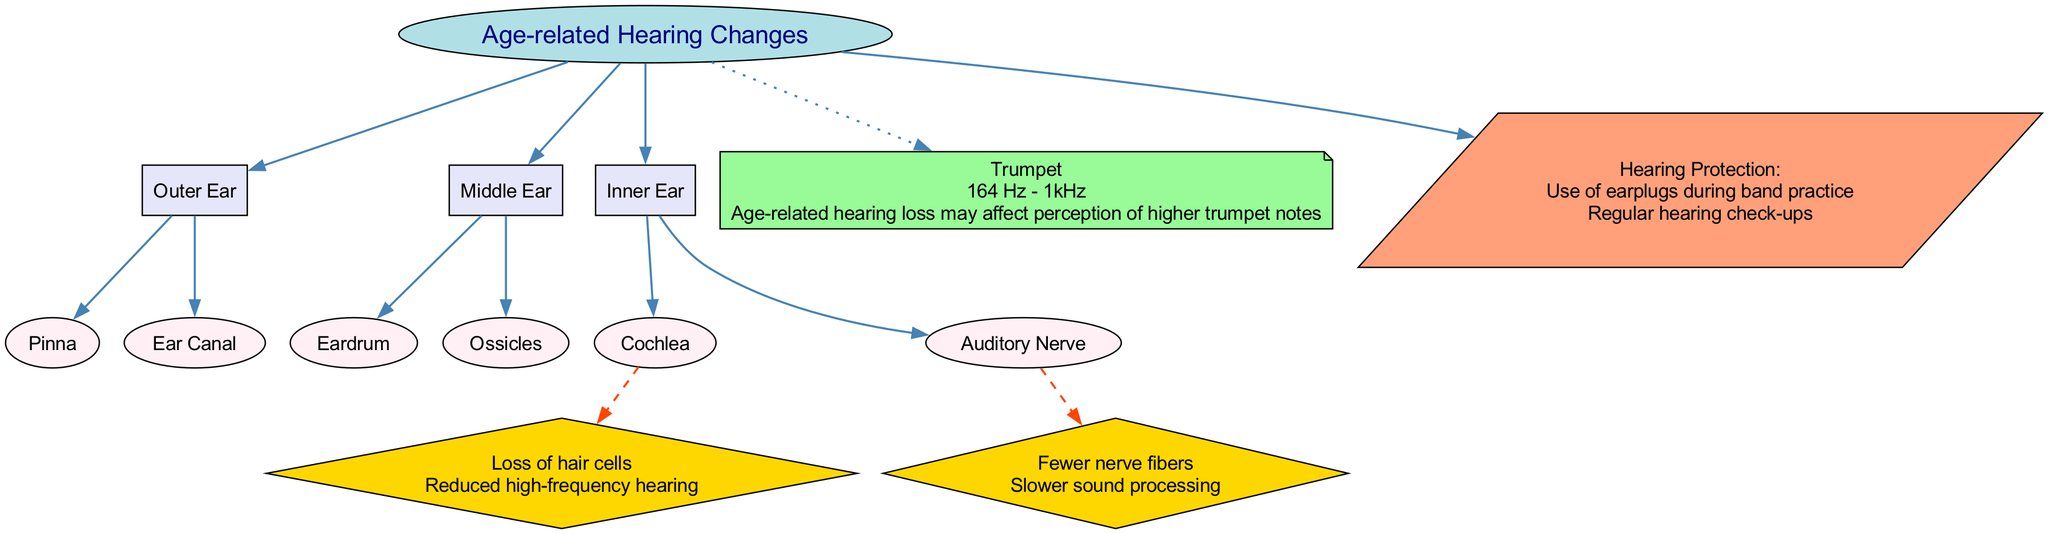What is the central topic of the diagram? The diagram's title indicates that the central topic is "Age-related Hearing Changes." Therefore, looking for the central node labeled as the main focus of the diagram leads directly to this answer.
Answer: Age-related Hearing Changes How many main structures are depicted? The diagram includes three main structures: Outer Ear, Middle Ear, and Inner Ear. By counting the nodes connected to the central topic, we arrive at this total.
Answer: 3 What component belongs to the Middle Ear? The component "Ossicles" is listed under the Middle Ear section in the diagram. Identifying the components associated with each main structure will provide the answer.
Answer: Ossicles What change occurs in the Cochlea with age? The diagram states "Loss of hair cells" as the age-related change in the Cochlea. This answer is obtained directly from the node corresponding to Cochlea's changes.
Answer: Loss of hair cells What impact does age-related hearing loss have on the trumpet? The diagram indicates that "Age-related hearing loss may affect perception of higher trumpet notes." Combining the musical relevance of the trumpet with the section on age-related changes gives this outcome.
Answer: Perception of higher trumpet notes How does the age-related change in the Auditory Nerve affect sound processing? According to the diagram, the age-related change in the Auditory Nerve is "Fewer nerve fibers," which results in "Slower sound processing." By analyzing the cause-and-effect relationship shown in the connection, we find the answer.
Answer: Slower sound processing What are two suggested methods for hearing protection? The diagram lists "Use of earplugs during band practice" and "Regular hearing check-ups" under the hearing protection section. By inspecting the relevant node, we can gather this information.
Answer: Use of earplugs during band practice; Regular hearing check-ups Which frequency range does the trumpet cover? The diagram specifies that the frequency range of the trumpet is "164 Hz - 1kHz," which is stated directly in the information related to musical relevance.
Answer: 164 Hz - 1kHz What is the effect of losing hair cells in the Cochlea? The diagram indicates that the loss of hair cells leads to "Reduced high-frequency hearing." By linking the age-related change to its effect, this conclusion is drawn.
Answer: Reduced high-frequency hearing 